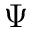Convert formula to latex. <formula><loc_0><loc_0><loc_500><loc_500>\Psi</formula> 